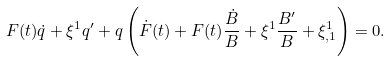<formula> <loc_0><loc_0><loc_500><loc_500>F ( t ) \dot { q } + \xi ^ { 1 } { q } ^ { \prime } + q \left ( \dot { F } ( t ) + F ( t ) \frac { \dot { B } } { B } + \xi ^ { 1 } \frac { B ^ { \prime } } { B } + \xi ^ { 1 } _ { , 1 } \right ) = 0 .</formula> 